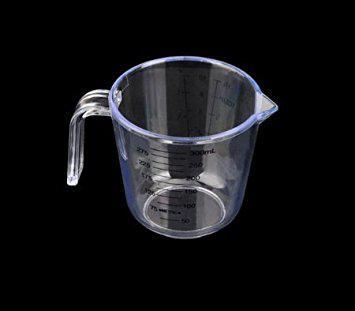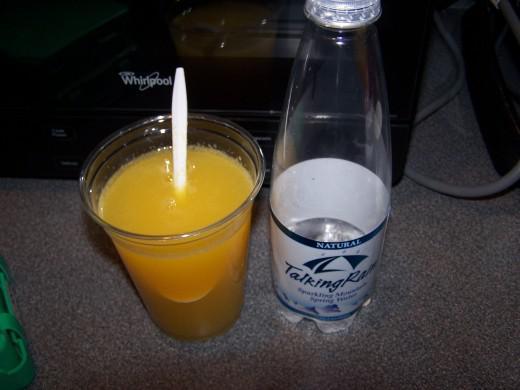The first image is the image on the left, the second image is the image on the right. Assess this claim about the two images: "The left image shows a cylindrical glass with liquid and a stirring spoon inside.". Correct or not? Answer yes or no. No. 